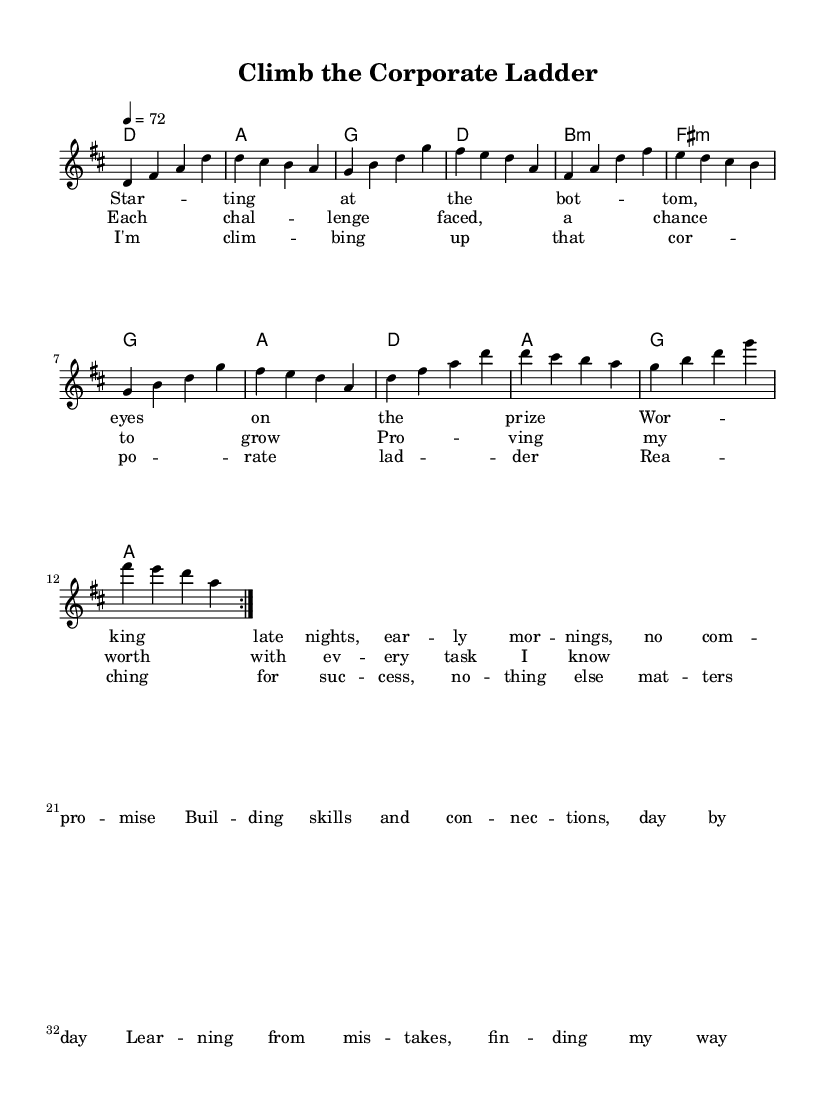What is the key signature of this music? The key signature is D major, which has two sharps (F# and C#). This can be identified at the beginning of the sheet music where the key signature is indicated.
Answer: D major What is the time signature of this music? The time signature is 4/4, which means there are four beats in each measure and the quarter note gets one beat. This can be seen at the beginning next to the key signature.
Answer: 4/4 What is the tempo marking of this music? The tempo marking is 72 beats per minute, shown by "4 = 72" in the tempo indication section at the beginning of the sheet music.
Answer: 72 How many verses are there in the lyrics? There are two verses presented in the lyrics, as seen by the lyric sections labeled 'verse' and 'prechorus' in the music. This means that the verse section is repeated after the first chorus section.
Answer: Two In which section do the lyrics begin with "Each challenge faced, a chance to grow"? These lyrics appear in the prechorus section of the song, which is clearly labeled in the sheet music after the verse section.
Answer: Prechorus What is the first chord in the score? The first chord in the score is D major, as noted in the harmonies section where it follows the global music parameters.
Answer: D What is the main theme reflected in the lyrics of the chorus? The main theme is career progress, as the lyrics express the desire to succeed and advance in a corporate environment as indicated in the chorus section.
Answer: Career progress 